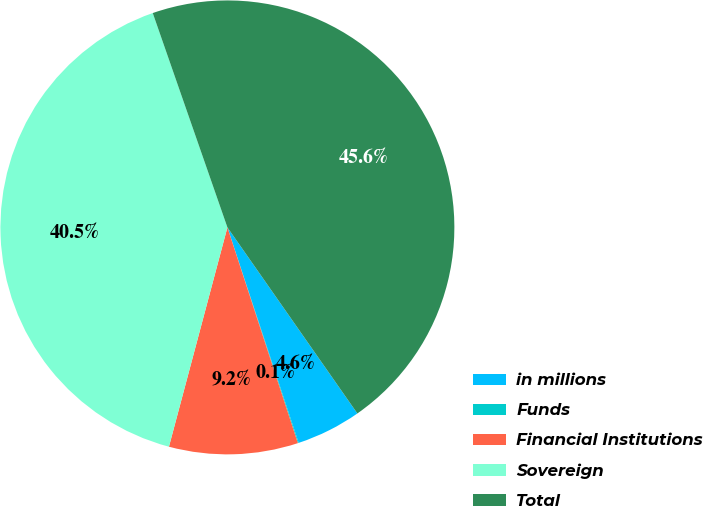<chart> <loc_0><loc_0><loc_500><loc_500><pie_chart><fcel>in millions<fcel>Funds<fcel>Financial Institutions<fcel>Sovereign<fcel>Total<nl><fcel>4.62%<fcel>0.06%<fcel>9.17%<fcel>40.52%<fcel>45.63%<nl></chart> 